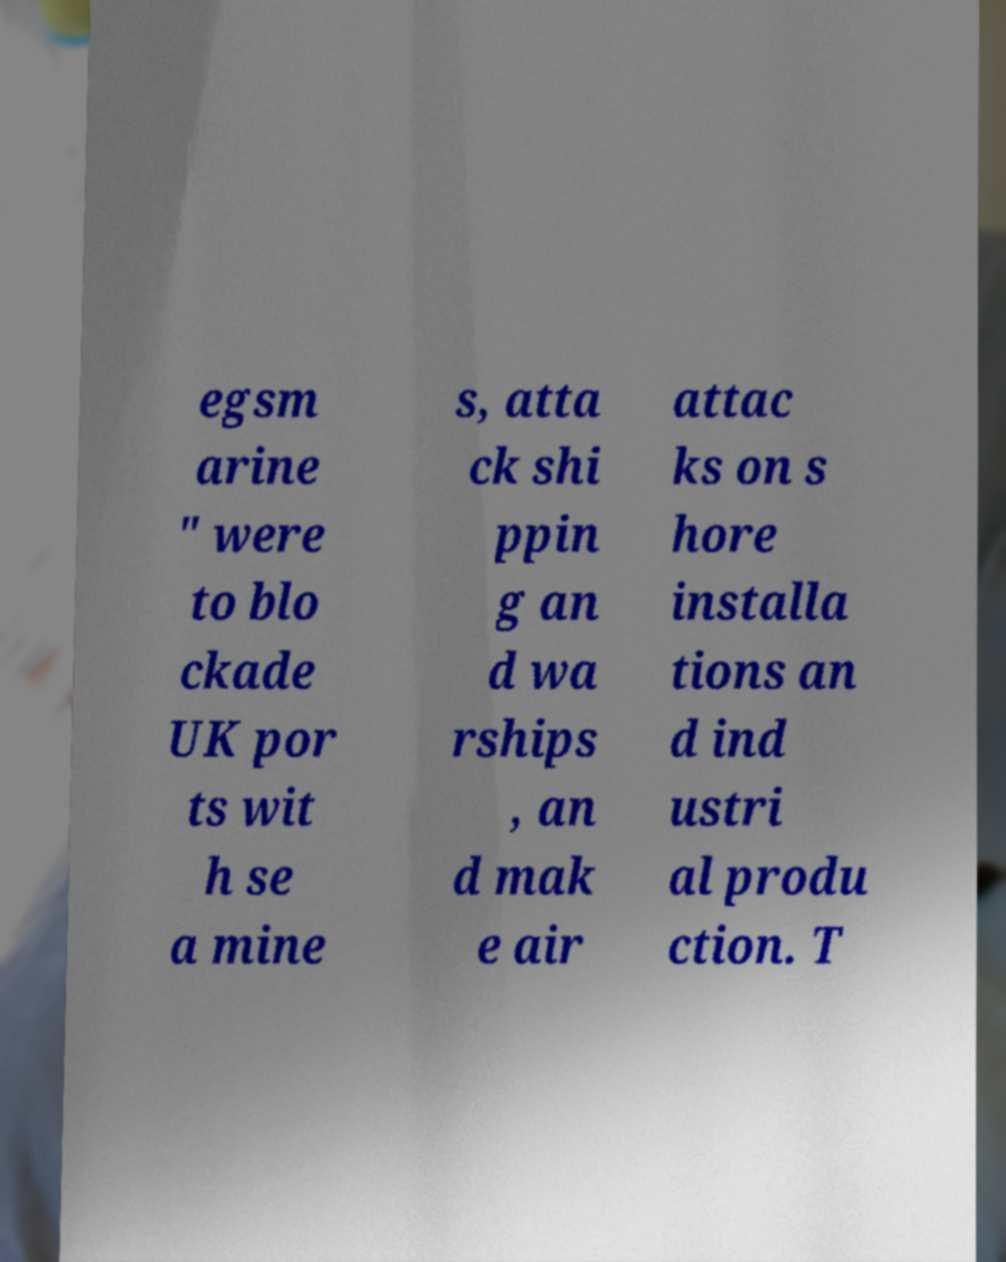Can you accurately transcribe the text from the provided image for me? egsm arine " were to blo ckade UK por ts wit h se a mine s, atta ck shi ppin g an d wa rships , an d mak e air attac ks on s hore installa tions an d ind ustri al produ ction. T 